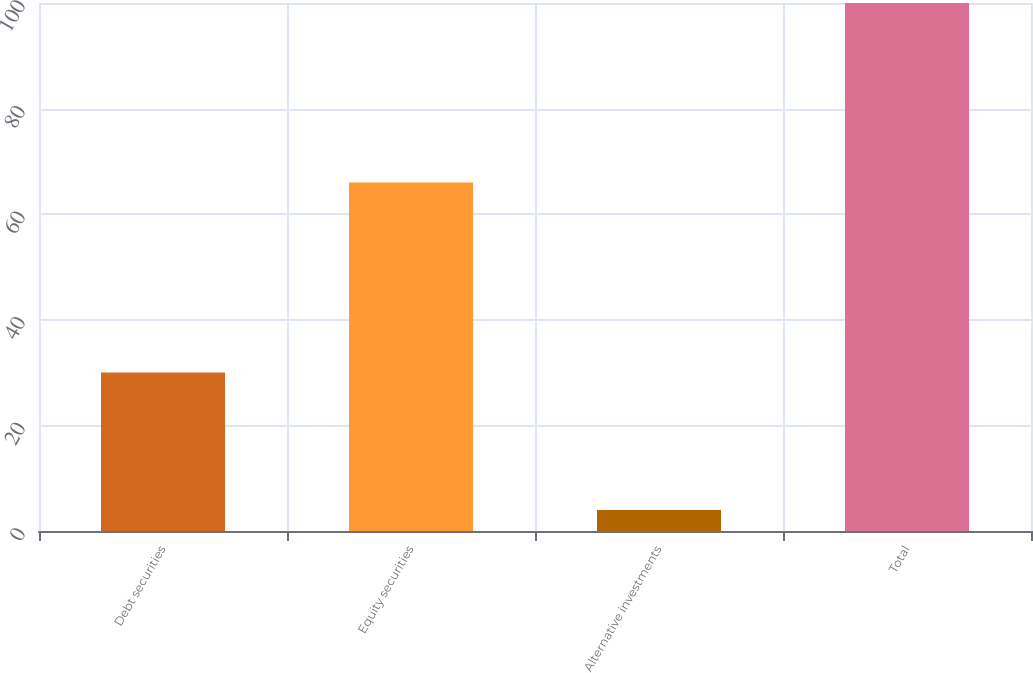Convert chart to OTSL. <chart><loc_0><loc_0><loc_500><loc_500><bar_chart><fcel>Debt securities<fcel>Equity securities<fcel>Alternative investments<fcel>Total<nl><fcel>30<fcel>66<fcel>4<fcel>100<nl></chart> 